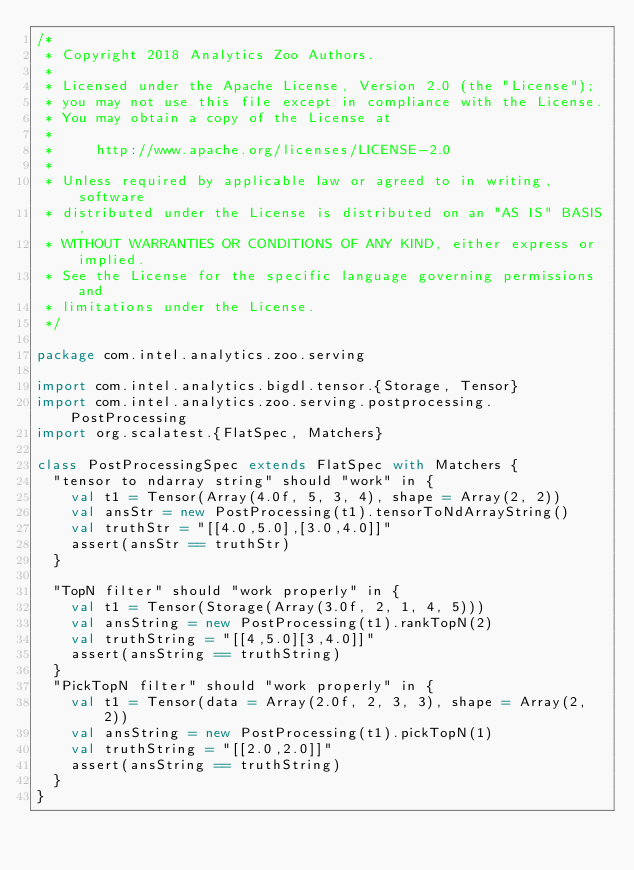<code> <loc_0><loc_0><loc_500><loc_500><_Scala_>/*
 * Copyright 2018 Analytics Zoo Authors.
 *
 * Licensed under the Apache License, Version 2.0 (the "License");
 * you may not use this file except in compliance with the License.
 * You may obtain a copy of the License at
 *
 *     http://www.apache.org/licenses/LICENSE-2.0
 *
 * Unless required by applicable law or agreed to in writing, software
 * distributed under the License is distributed on an "AS IS" BASIS,
 * WITHOUT WARRANTIES OR CONDITIONS OF ANY KIND, either express or implied.
 * See the License for the specific language governing permissions and
 * limitations under the License.
 */

package com.intel.analytics.zoo.serving

import com.intel.analytics.bigdl.tensor.{Storage, Tensor}
import com.intel.analytics.zoo.serving.postprocessing.PostProcessing
import org.scalatest.{FlatSpec, Matchers}

class PostProcessingSpec extends FlatSpec with Matchers {
  "tensor to ndarray string" should "work" in {
    val t1 = Tensor(Array(4.0f, 5, 3, 4), shape = Array(2, 2))
    val ansStr = new PostProcessing(t1).tensorToNdArrayString()
    val truthStr = "[[4.0,5.0],[3.0,4.0]]"
    assert(ansStr == truthStr)
  }

  "TopN filter" should "work properly" in {
    val t1 = Tensor(Storage(Array(3.0f, 2, 1, 4, 5)))
    val ansString = new PostProcessing(t1).rankTopN(2)
    val truthString = "[[4,5.0][3,4.0]]"
    assert(ansString == truthString)
  }
  "PickTopN filter" should "work properly" in {
    val t1 = Tensor(data = Array(2.0f, 2, 3, 3), shape = Array(2, 2))
    val ansString = new PostProcessing(t1).pickTopN(1)
    val truthString = "[[2.0,2.0]]"
    assert(ansString == truthString)
  }
}
</code> 